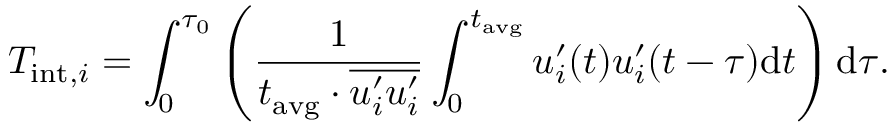<formula> <loc_0><loc_0><loc_500><loc_500>T _ { i n t , i } = \int _ { 0 } ^ { \tau _ { 0 } } \left ( \frac { 1 } { t _ { a v g } \cdot \overline { { u _ { i } ^ { \prime } u _ { i } ^ { \prime } } } } \int _ { 0 } ^ { t _ { a v g } } u _ { i } ^ { \prime } ( t ) u _ { i } ^ { \prime } ( t - \tau ) \mathrm d t \right ) \mathrm d \tau .</formula> 